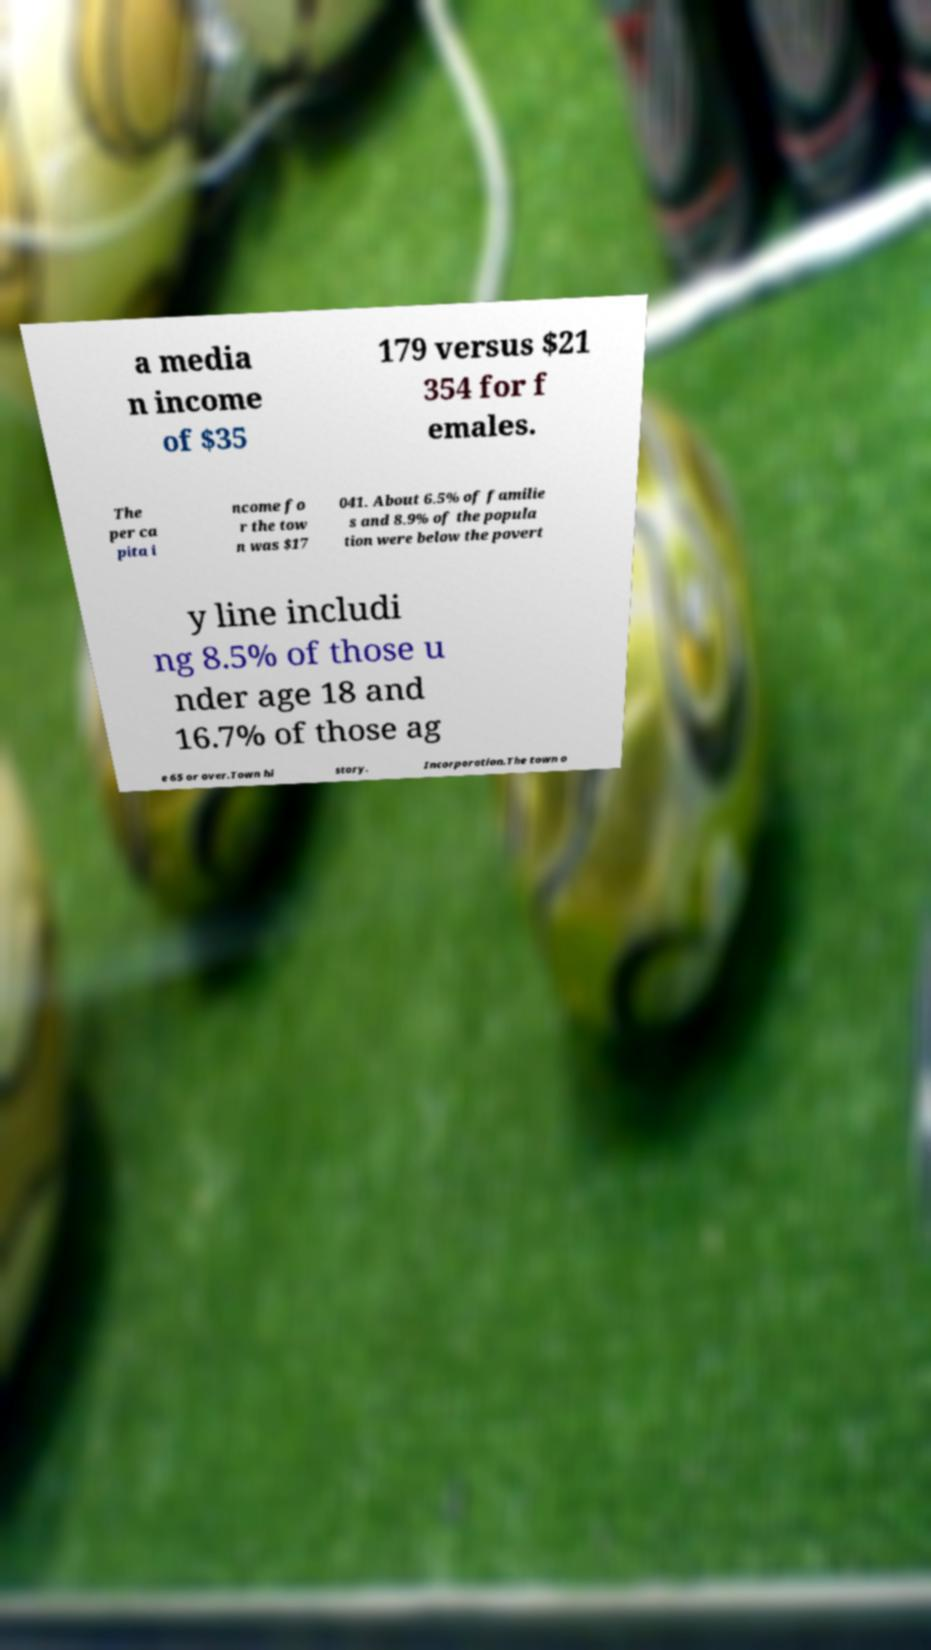For documentation purposes, I need the text within this image transcribed. Could you provide that? a media n income of $35 179 versus $21 354 for f emales. The per ca pita i ncome fo r the tow n was $17 041. About 6.5% of familie s and 8.9% of the popula tion were below the povert y line includi ng 8.5% of those u nder age 18 and 16.7% of those ag e 65 or over.Town hi story. Incorporation.The town o 